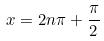Convert formula to latex. <formula><loc_0><loc_0><loc_500><loc_500>x = 2 n \pi + \frac { \pi } { 2 }</formula> 